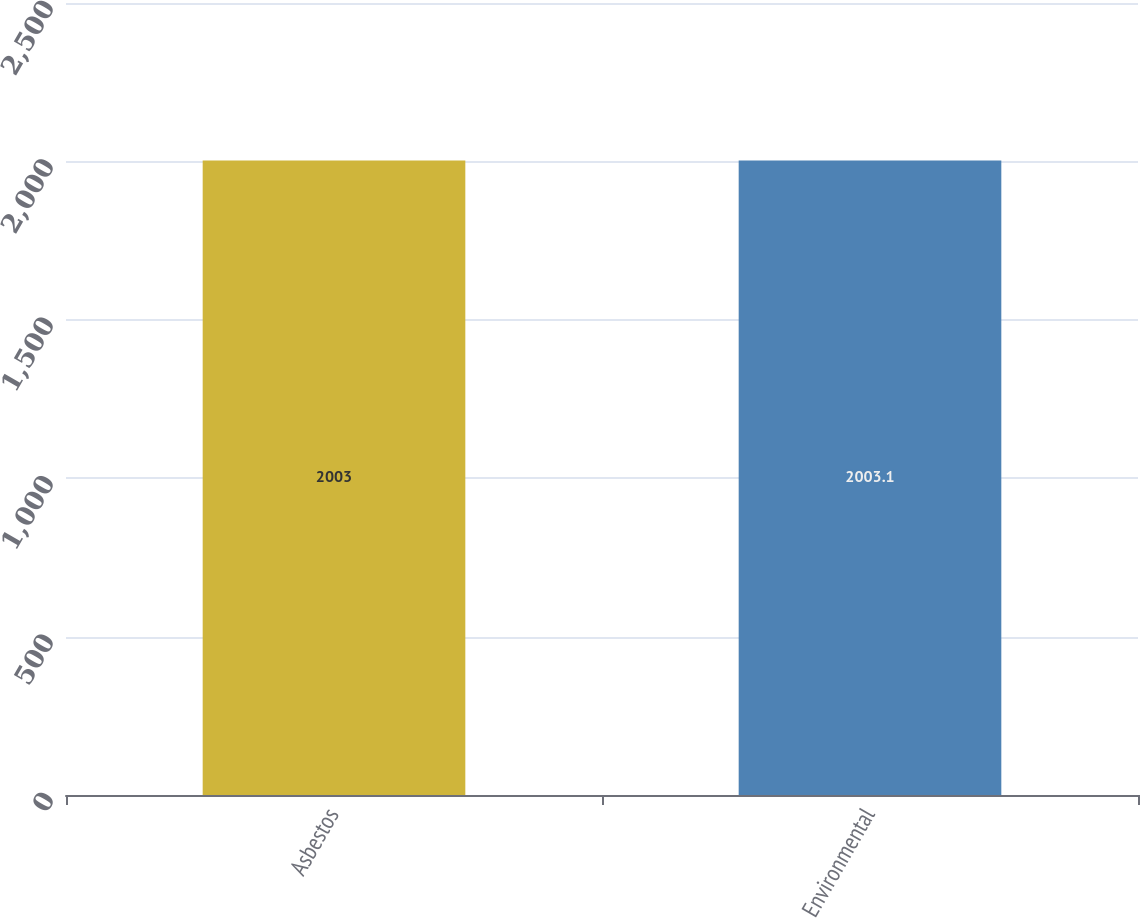<chart> <loc_0><loc_0><loc_500><loc_500><bar_chart><fcel>Asbestos<fcel>Environmental<nl><fcel>2003<fcel>2003.1<nl></chart> 